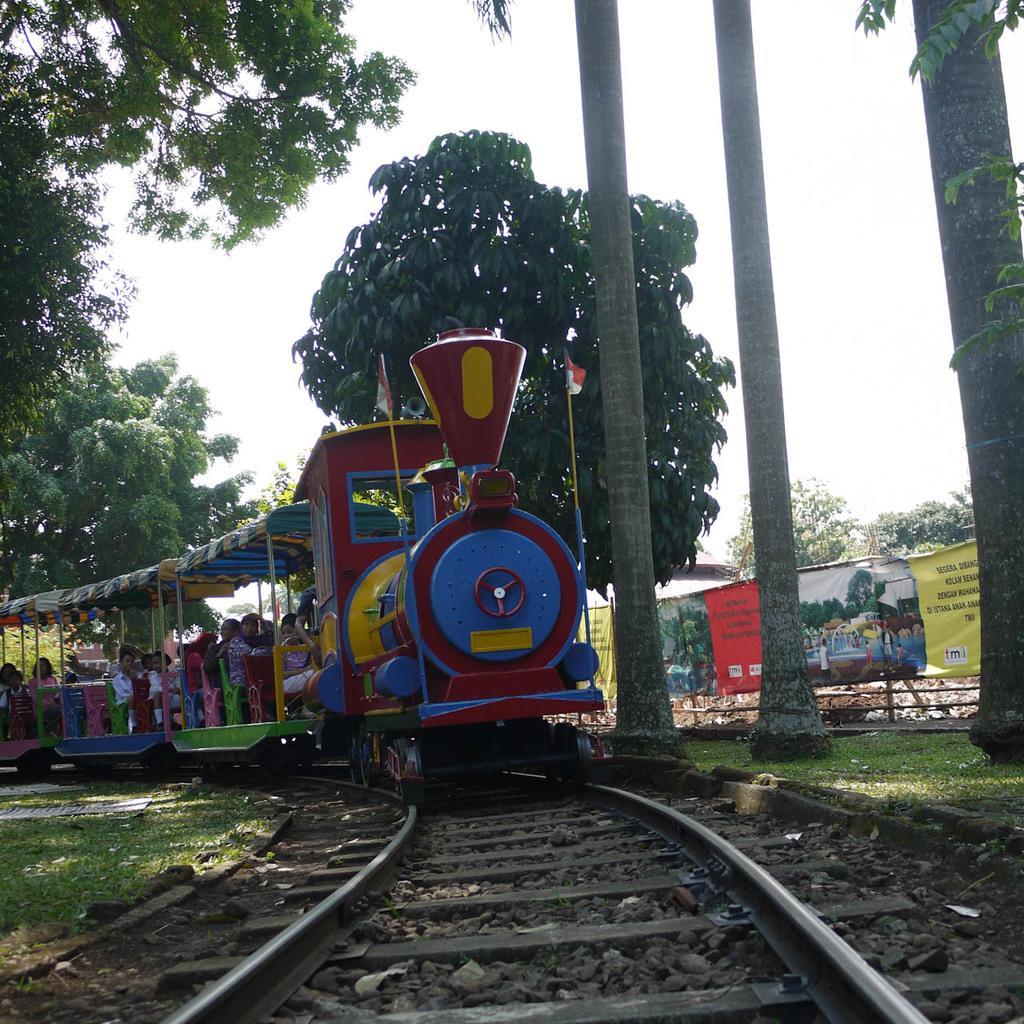Can you describe this image briefly? In this image we can see a train in which few people are sitting is moving on the railway track. Here we can see the grass, banners, trees and the sky in the background. 